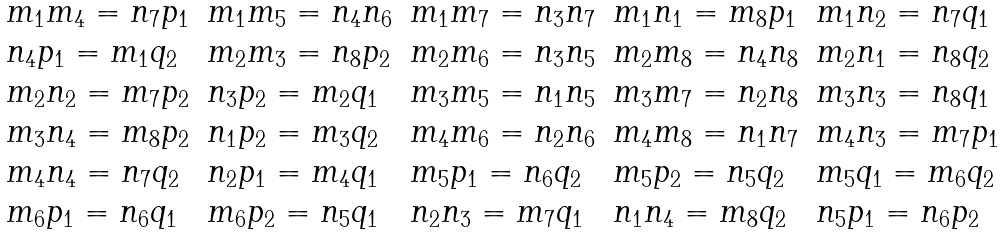Convert formula to latex. <formula><loc_0><loc_0><loc_500><loc_500>\begin{array} { l l l l l } m _ { 1 } m _ { 4 } = n _ { 7 } p _ { 1 } & m _ { 1 } m _ { 5 } = n _ { 4 } n _ { 6 } & m _ { 1 } m _ { 7 } = n _ { 3 } n _ { 7 } & m _ { 1 } n _ { 1 } = m _ { 8 } p _ { 1 } & m _ { 1 } n _ { 2 } = n _ { 7 } q _ { 1 } \\ n _ { 4 } p _ { 1 } = m _ { 1 } q _ { 2 } & m _ { 2 } m _ { 3 } = n _ { 8 } p _ { 2 } & m _ { 2 } m _ { 6 } = n _ { 3 } n _ { 5 } & m _ { 2 } m _ { 8 } = n _ { 4 } n _ { 8 } & m _ { 2 } n _ { 1 } = n _ { 8 } q _ { 2 } \\ m _ { 2 } n _ { 2 } = m _ { 7 } p _ { 2 } & n _ { 3 } p _ { 2 } = m _ { 2 } q _ { 1 } & m _ { 3 } m _ { 5 } = n _ { 1 } n _ { 5 } & m _ { 3 } m _ { 7 } = n _ { 2 } n _ { 8 } & m _ { 3 } n _ { 3 } = n _ { 8 } q _ { 1 } \\ m _ { 3 } n _ { 4 } = m _ { 8 } p _ { 2 } & n _ { 1 } p _ { 2 } = m _ { 3 } q _ { 2 } & m _ { 4 } m _ { 6 } = n _ { 2 } n _ { 6 } & m _ { 4 } m _ { 8 } = n _ { 1 } n _ { 7 } & m _ { 4 } n _ { 3 } = m _ { 7 } p _ { 1 } \\ m _ { 4 } n _ { 4 } = n _ { 7 } q _ { 2 } & n _ { 2 } p _ { 1 } = m _ { 4 } q _ { 1 } & m _ { 5 } p _ { 1 } = n _ { 6 } q _ { 2 } & m _ { 5 } p _ { 2 } = n _ { 5 } q _ { 2 } & m _ { 5 } q _ { 1 } = m _ { 6 } q _ { 2 } \\ m _ { 6 } p _ { 1 } = n _ { 6 } q _ { 1 } & m _ { 6 } p _ { 2 } = n _ { 5 } q _ { 1 } & n _ { 2 } n _ { 3 } = m _ { 7 } q _ { 1 } & n _ { 1 } n _ { 4 } = m _ { 8 } q _ { 2 } & n _ { 5 } p _ { 1 } = n _ { 6 } p _ { 2 } \end{array}</formula> 